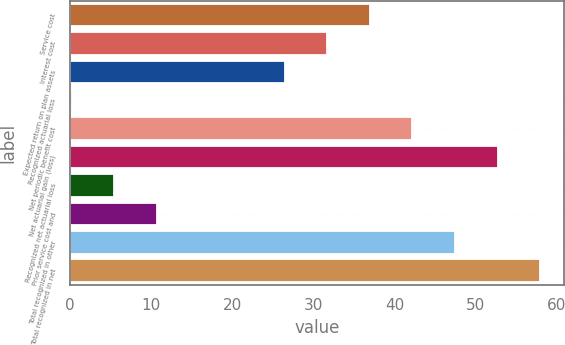Convert chart to OTSL. <chart><loc_0><loc_0><loc_500><loc_500><bar_chart><fcel>Service cost<fcel>Interest cost<fcel>Expected return on plan assets<fcel>Recognized actuarial loss<fcel>Net periodic benefit cost<fcel>Net actuarial gain (loss)<fcel>Recognized net actuarial loss<fcel>Prior service cost and<fcel>Total recognized in other<fcel>Total recognized in net<nl><fcel>36.95<fcel>31.7<fcel>26.45<fcel>0.2<fcel>42.2<fcel>52.7<fcel>5.45<fcel>10.7<fcel>47.45<fcel>57.95<nl></chart> 